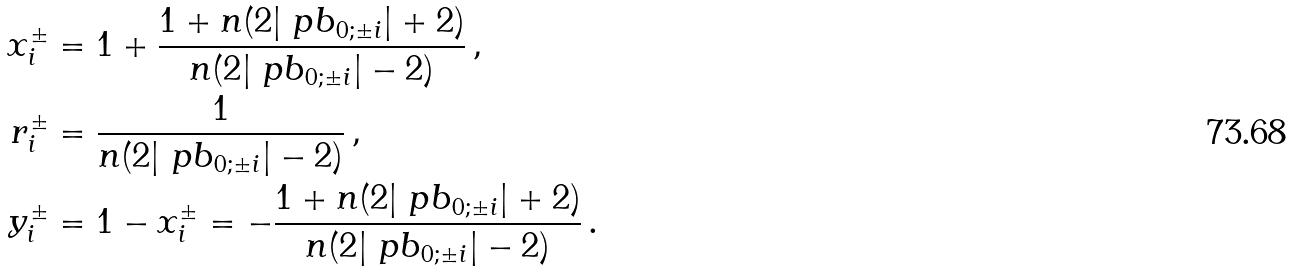Convert formula to latex. <formula><loc_0><loc_0><loc_500><loc_500>x ^ { \pm } _ { i } & = 1 + \frac { 1 + n ( 2 | \ p b _ { 0 ; \pm i } | + 2 ) } { n ( 2 | \ p b _ { 0 ; \pm i } | - 2 ) } \, , \\ r ^ { \pm } _ { i } & = \frac { 1 } { n ( 2 | \ p b _ { 0 ; \pm i } | - 2 ) } \, , \\ y ^ { \pm } _ { i } & = 1 - x ^ { \pm } _ { i } = - \frac { 1 + n ( 2 | \ p b _ { 0 ; \pm i } | + 2 ) } { n ( 2 | \ p b _ { 0 ; \pm i } | - 2 ) } \, .</formula> 